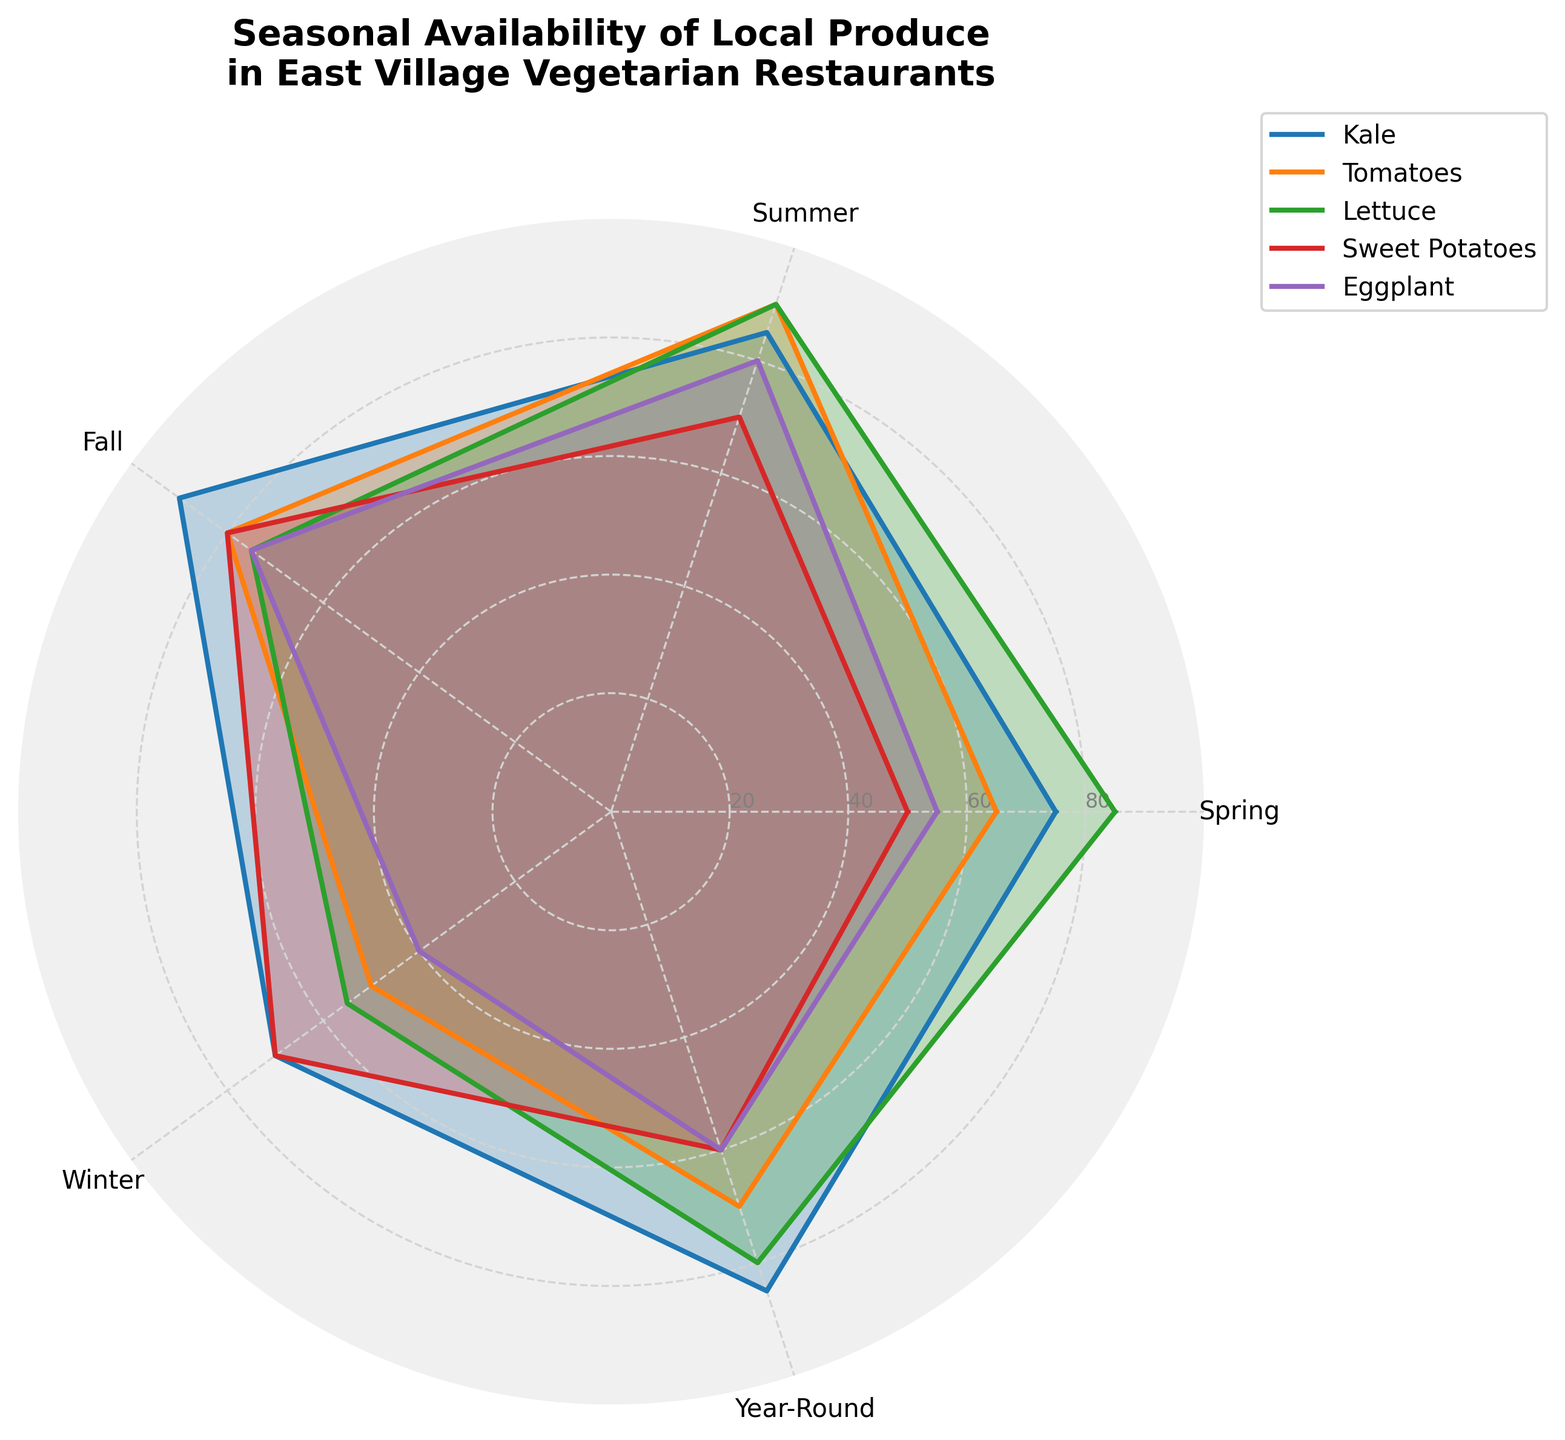What is the seasonal availability value of Kale in Summer? To find the availability value of Kale in Summer, locate the corresponding point on the radar chart where Kale intersects the summer axis.
Answer: 85 Which produce item has the highest availability in Fall? Compare the plotted values of all selected produce items for Fall on the radar chart, identifying the highest peak.
Answer: Kale Does Eggplant have higher availability in Spring or Winter? Compare the points for Eggplant on the Spring and Winter axes noting which value is higher.
Answer: Spring Which season shows the lowest availability for Sweet Potatoes? Find the values for Sweet Potatoes across all seasons on the radar chart and identify the lowest point.
Answer: Spring What are the two produce items with the closest availability values in Winter? Examine the values on the Winter axis for all selected produce items and identify which two are closest numerically.
Answer: Kale and Sweet Potatoes Which two seasons have the most similar availability value for Lettuce? Compare the plotted values for Lettuce across all seasons and identify the two seasons with the smallest difference.
Answer: Spring and Year-Round Comparing Kale and Tomatoes, which has higher average availability across all seasons? Calculate the average of the seasonal values for Kale and Tomatoes and compare the results.
Answer: Kale Which season features the most variability in the availability of different produce items? Assess the range of values for each season on the radar chart and determine the season with the widest spread of values indicating variability.
Answer: Winter Is there any produce item that shows a greater availability in Fall than in Summer? Compare Fall and Summer availability values for all selected produce items, identifying if any produce has a higher value in Fall.
Answer: No Taking the values of Kale and combining Spring and Fall, what is their sum? Add the Spring (75) and Fall (90) values for Kale directly.
Answer: 165 